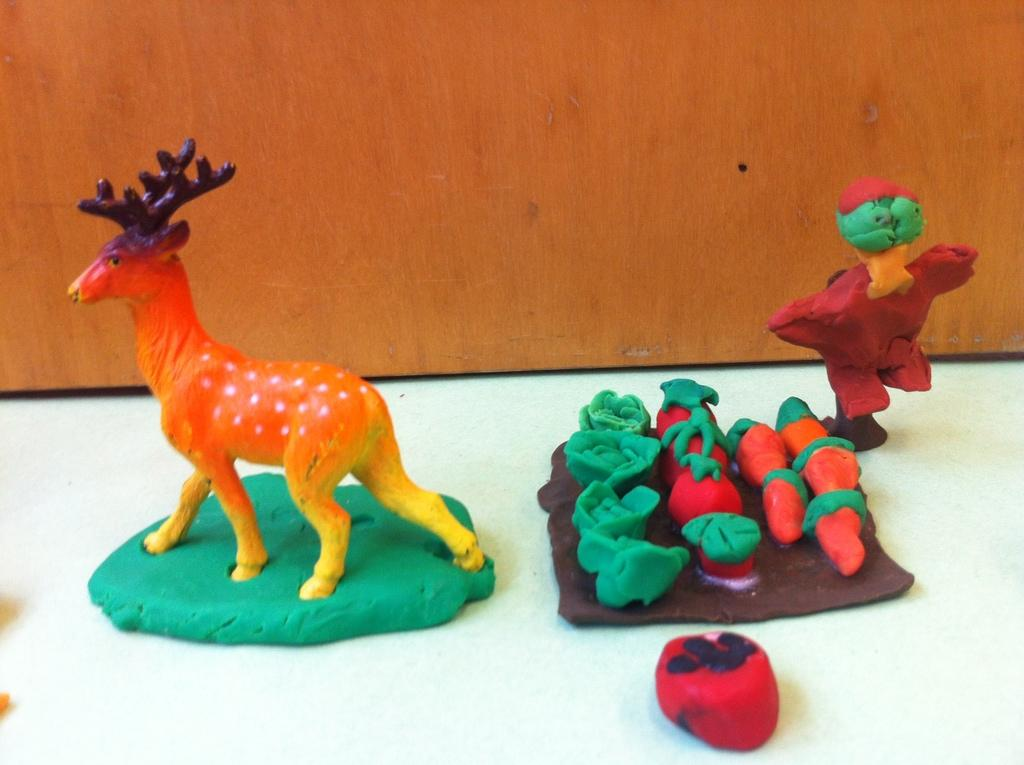What type of items can be seen on the table in the image? There are clay items on the table. Can you describe one of the clay items in detail? There is a statue of a deer made with clay. What other clay item can be seen on the table? There is a plate of fruits and vegetables made with clay. How many squares can be seen on the plate of fruits and vegetables made with clay? There are no squares present on the plate of fruits and vegetables made with clay in the image. 